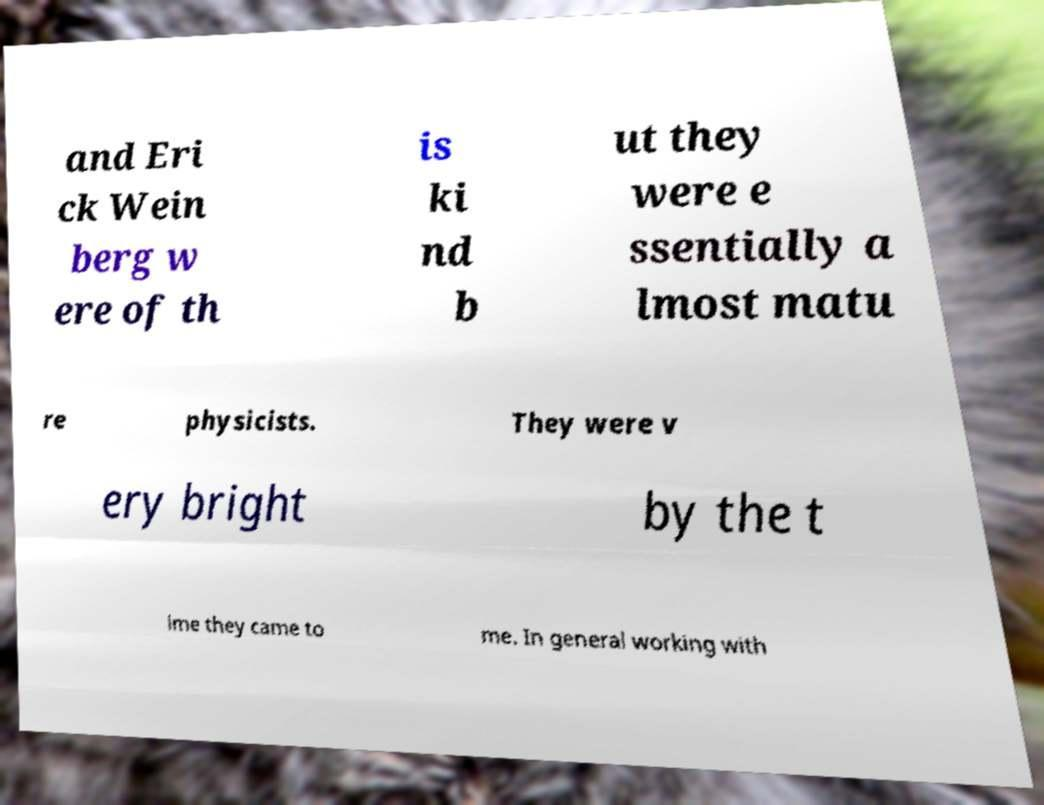What does the statement about these individuals being 'almost mature physicists' imply about their status or phase in their career? The statement likely implies that Erick Weinberg and the others mentioned were in the advanced stages of their training or early in their professional careers. They were not yet fully established but had developed significant competence and recognition in their field, suggesting they were on the brink of full maturity in their professional roles. 